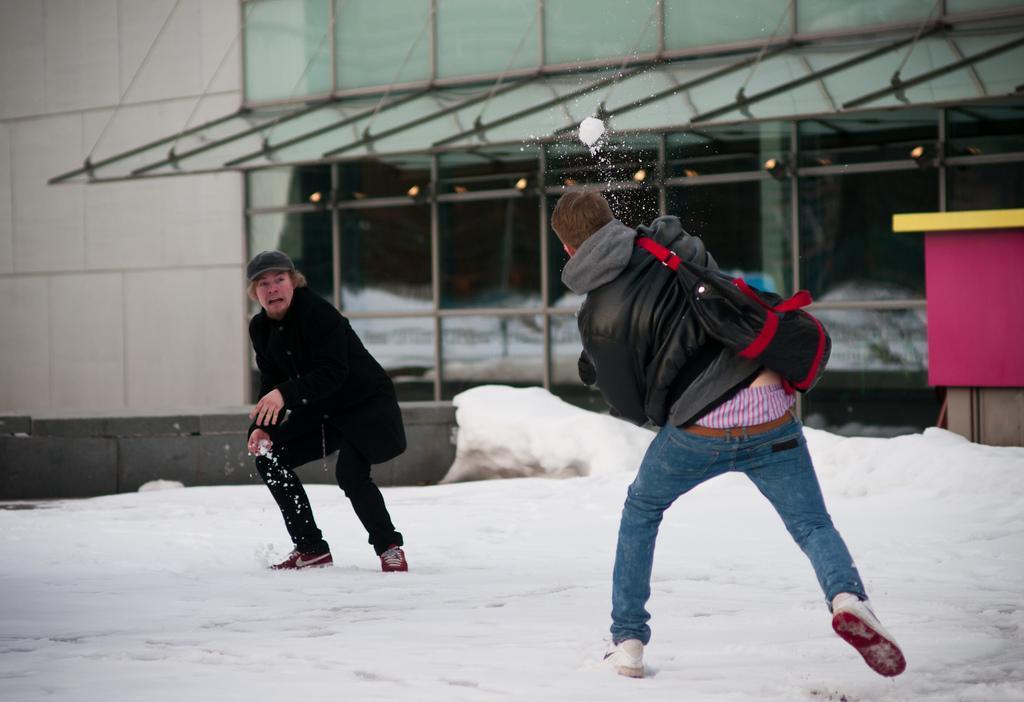Describe this image in one or two sentences. In this image we can see the persons standing and playing with snow. In the background, we can see the building with windows and box at the right side. 